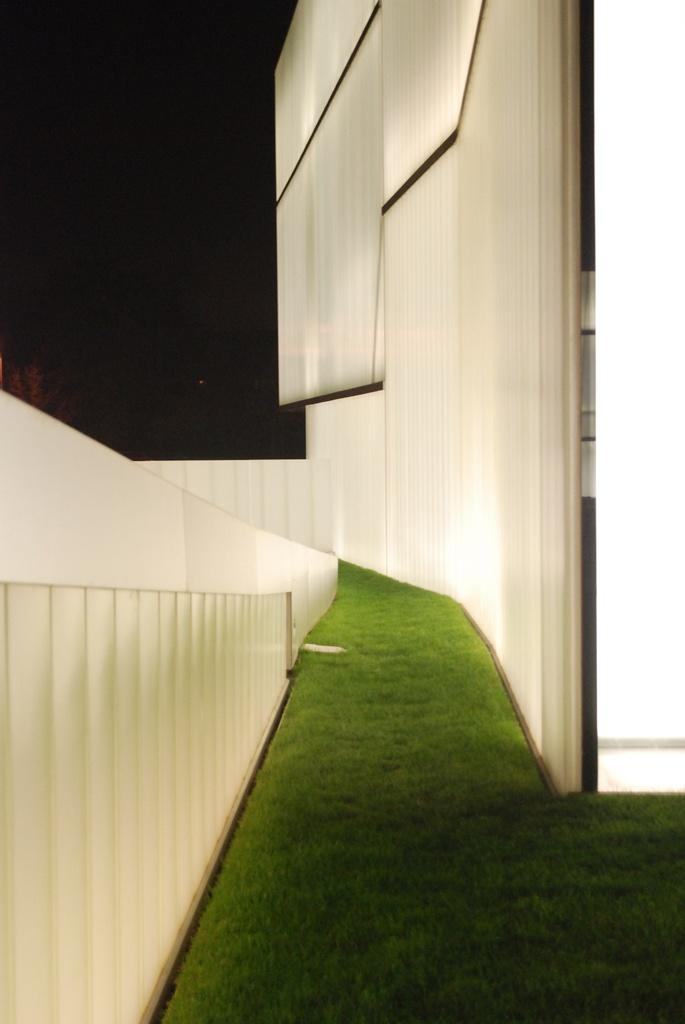What color are the walls in the image? The walls in the image are white. What type of vegetation can be seen in the image? There is green grass visible in the image. How would you describe the overall lighting or color scheme of the image? The background of the image is dark. What type of shoe is being served for dinner in the image? There is no shoe or dinner present in the image. Can you see any railway tracks in the image? There are no railway tracks visible in the image. 